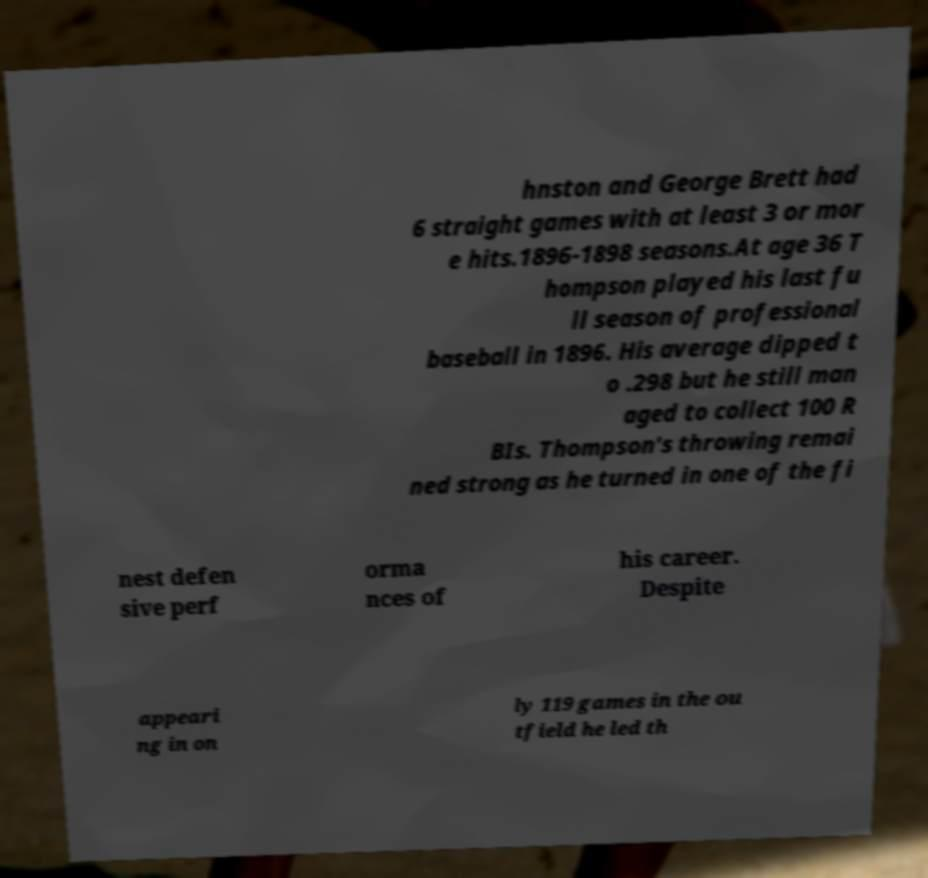Can you read and provide the text displayed in the image?This photo seems to have some interesting text. Can you extract and type it out for me? hnston and George Brett had 6 straight games with at least 3 or mor e hits.1896-1898 seasons.At age 36 T hompson played his last fu ll season of professional baseball in 1896. His average dipped t o .298 but he still man aged to collect 100 R BIs. Thompson's throwing remai ned strong as he turned in one of the fi nest defen sive perf orma nces of his career. Despite appeari ng in on ly 119 games in the ou tfield he led th 